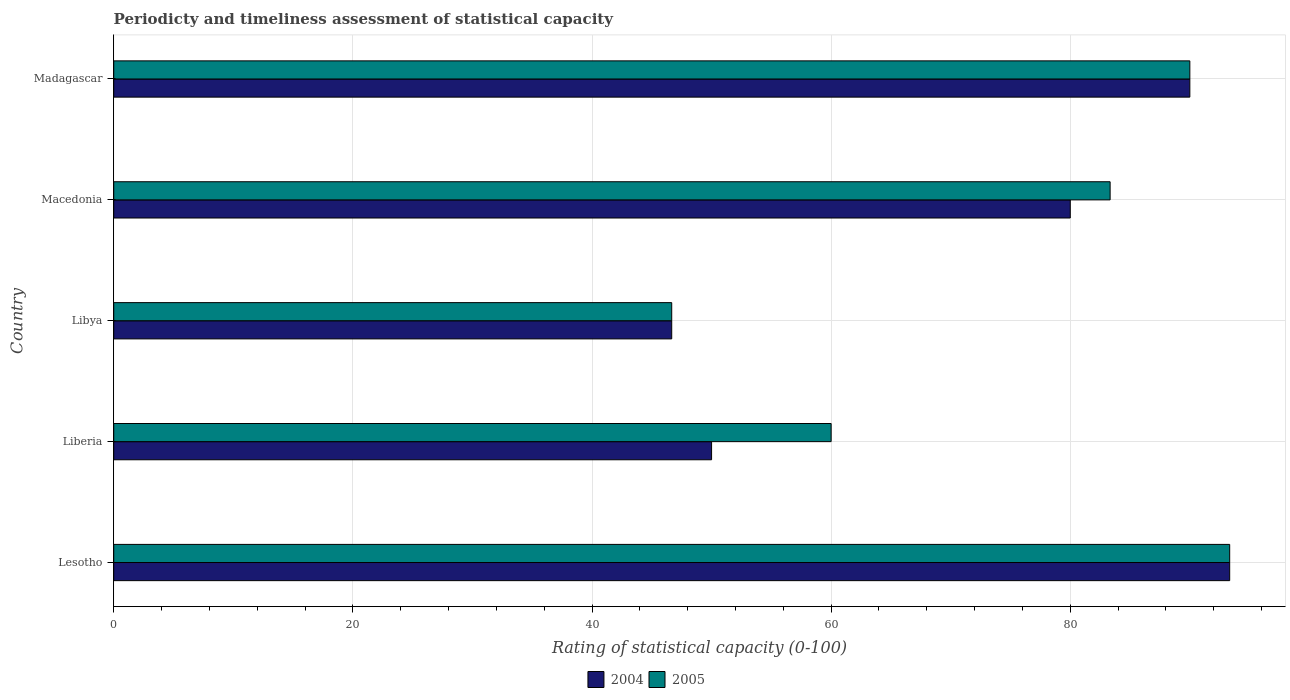Are the number of bars per tick equal to the number of legend labels?
Make the answer very short. Yes. How many bars are there on the 2nd tick from the top?
Give a very brief answer. 2. How many bars are there on the 1st tick from the bottom?
Your response must be concise. 2. What is the label of the 3rd group of bars from the top?
Give a very brief answer. Libya. In how many cases, is the number of bars for a given country not equal to the number of legend labels?
Your answer should be compact. 0. What is the rating of statistical capacity in 2005 in Libya?
Your response must be concise. 46.67. Across all countries, what is the maximum rating of statistical capacity in 2005?
Provide a short and direct response. 93.33. Across all countries, what is the minimum rating of statistical capacity in 2005?
Give a very brief answer. 46.67. In which country was the rating of statistical capacity in 2004 maximum?
Ensure brevity in your answer.  Lesotho. In which country was the rating of statistical capacity in 2005 minimum?
Provide a succinct answer. Libya. What is the total rating of statistical capacity in 2004 in the graph?
Keep it short and to the point. 360. What is the difference between the rating of statistical capacity in 2005 in Libya and the rating of statistical capacity in 2004 in Lesotho?
Give a very brief answer. -46.67. What is the average rating of statistical capacity in 2004 per country?
Keep it short and to the point. 72. What is the ratio of the rating of statistical capacity in 2005 in Liberia to that in Libya?
Provide a succinct answer. 1.29. Is the rating of statistical capacity in 2005 in Lesotho less than that in Libya?
Make the answer very short. No. What is the difference between the highest and the second highest rating of statistical capacity in 2004?
Your answer should be very brief. 3.33. What is the difference between the highest and the lowest rating of statistical capacity in 2004?
Your answer should be compact. 46.67. What does the 1st bar from the bottom in Libya represents?
Provide a short and direct response. 2004. How many bars are there?
Ensure brevity in your answer.  10. Does the graph contain any zero values?
Make the answer very short. No. How many legend labels are there?
Your answer should be very brief. 2. How are the legend labels stacked?
Ensure brevity in your answer.  Horizontal. What is the title of the graph?
Make the answer very short. Periodicty and timeliness assessment of statistical capacity. Does "1984" appear as one of the legend labels in the graph?
Offer a very short reply. No. What is the label or title of the X-axis?
Your answer should be compact. Rating of statistical capacity (0-100). What is the label or title of the Y-axis?
Your answer should be compact. Country. What is the Rating of statistical capacity (0-100) in 2004 in Lesotho?
Your answer should be very brief. 93.33. What is the Rating of statistical capacity (0-100) of 2005 in Lesotho?
Keep it short and to the point. 93.33. What is the Rating of statistical capacity (0-100) in 2004 in Liberia?
Offer a terse response. 50. What is the Rating of statistical capacity (0-100) in 2005 in Liberia?
Your answer should be very brief. 60. What is the Rating of statistical capacity (0-100) of 2004 in Libya?
Offer a very short reply. 46.67. What is the Rating of statistical capacity (0-100) in 2005 in Libya?
Your answer should be compact. 46.67. What is the Rating of statistical capacity (0-100) of 2004 in Macedonia?
Offer a very short reply. 80. What is the Rating of statistical capacity (0-100) of 2005 in Macedonia?
Offer a very short reply. 83.33. What is the Rating of statistical capacity (0-100) of 2004 in Madagascar?
Provide a succinct answer. 90. What is the Rating of statistical capacity (0-100) in 2005 in Madagascar?
Make the answer very short. 90. Across all countries, what is the maximum Rating of statistical capacity (0-100) of 2004?
Keep it short and to the point. 93.33. Across all countries, what is the maximum Rating of statistical capacity (0-100) in 2005?
Provide a short and direct response. 93.33. Across all countries, what is the minimum Rating of statistical capacity (0-100) in 2004?
Offer a terse response. 46.67. Across all countries, what is the minimum Rating of statistical capacity (0-100) in 2005?
Your response must be concise. 46.67. What is the total Rating of statistical capacity (0-100) in 2004 in the graph?
Offer a very short reply. 360. What is the total Rating of statistical capacity (0-100) of 2005 in the graph?
Your answer should be compact. 373.33. What is the difference between the Rating of statistical capacity (0-100) of 2004 in Lesotho and that in Liberia?
Provide a succinct answer. 43.33. What is the difference between the Rating of statistical capacity (0-100) of 2005 in Lesotho and that in Liberia?
Offer a very short reply. 33.33. What is the difference between the Rating of statistical capacity (0-100) in 2004 in Lesotho and that in Libya?
Provide a short and direct response. 46.67. What is the difference between the Rating of statistical capacity (0-100) of 2005 in Lesotho and that in Libya?
Keep it short and to the point. 46.67. What is the difference between the Rating of statistical capacity (0-100) of 2004 in Lesotho and that in Macedonia?
Give a very brief answer. 13.33. What is the difference between the Rating of statistical capacity (0-100) in 2005 in Lesotho and that in Macedonia?
Make the answer very short. 10. What is the difference between the Rating of statistical capacity (0-100) of 2005 in Lesotho and that in Madagascar?
Offer a terse response. 3.33. What is the difference between the Rating of statistical capacity (0-100) of 2005 in Liberia and that in Libya?
Keep it short and to the point. 13.33. What is the difference between the Rating of statistical capacity (0-100) of 2004 in Liberia and that in Macedonia?
Give a very brief answer. -30. What is the difference between the Rating of statistical capacity (0-100) of 2005 in Liberia and that in Macedonia?
Provide a succinct answer. -23.33. What is the difference between the Rating of statistical capacity (0-100) in 2004 in Libya and that in Macedonia?
Your response must be concise. -33.33. What is the difference between the Rating of statistical capacity (0-100) of 2005 in Libya and that in Macedonia?
Your answer should be very brief. -36.67. What is the difference between the Rating of statistical capacity (0-100) of 2004 in Libya and that in Madagascar?
Provide a short and direct response. -43.33. What is the difference between the Rating of statistical capacity (0-100) in 2005 in Libya and that in Madagascar?
Give a very brief answer. -43.33. What is the difference between the Rating of statistical capacity (0-100) in 2004 in Macedonia and that in Madagascar?
Your answer should be compact. -10. What is the difference between the Rating of statistical capacity (0-100) of 2005 in Macedonia and that in Madagascar?
Your response must be concise. -6.67. What is the difference between the Rating of statistical capacity (0-100) of 2004 in Lesotho and the Rating of statistical capacity (0-100) of 2005 in Liberia?
Offer a very short reply. 33.33. What is the difference between the Rating of statistical capacity (0-100) in 2004 in Lesotho and the Rating of statistical capacity (0-100) in 2005 in Libya?
Your answer should be compact. 46.67. What is the difference between the Rating of statistical capacity (0-100) of 2004 in Lesotho and the Rating of statistical capacity (0-100) of 2005 in Macedonia?
Your answer should be very brief. 10. What is the difference between the Rating of statistical capacity (0-100) of 2004 in Lesotho and the Rating of statistical capacity (0-100) of 2005 in Madagascar?
Make the answer very short. 3.33. What is the difference between the Rating of statistical capacity (0-100) of 2004 in Liberia and the Rating of statistical capacity (0-100) of 2005 in Libya?
Your answer should be very brief. 3.33. What is the difference between the Rating of statistical capacity (0-100) of 2004 in Liberia and the Rating of statistical capacity (0-100) of 2005 in Macedonia?
Make the answer very short. -33.33. What is the difference between the Rating of statistical capacity (0-100) of 2004 in Liberia and the Rating of statistical capacity (0-100) of 2005 in Madagascar?
Provide a succinct answer. -40. What is the difference between the Rating of statistical capacity (0-100) of 2004 in Libya and the Rating of statistical capacity (0-100) of 2005 in Macedonia?
Provide a succinct answer. -36.67. What is the difference between the Rating of statistical capacity (0-100) in 2004 in Libya and the Rating of statistical capacity (0-100) in 2005 in Madagascar?
Make the answer very short. -43.33. What is the difference between the Rating of statistical capacity (0-100) in 2004 in Macedonia and the Rating of statistical capacity (0-100) in 2005 in Madagascar?
Provide a succinct answer. -10. What is the average Rating of statistical capacity (0-100) of 2004 per country?
Keep it short and to the point. 72. What is the average Rating of statistical capacity (0-100) of 2005 per country?
Your response must be concise. 74.67. What is the difference between the Rating of statistical capacity (0-100) in 2004 and Rating of statistical capacity (0-100) in 2005 in Libya?
Your response must be concise. 0. What is the difference between the Rating of statistical capacity (0-100) in 2004 and Rating of statistical capacity (0-100) in 2005 in Macedonia?
Keep it short and to the point. -3.33. What is the difference between the Rating of statistical capacity (0-100) in 2004 and Rating of statistical capacity (0-100) in 2005 in Madagascar?
Your response must be concise. 0. What is the ratio of the Rating of statistical capacity (0-100) of 2004 in Lesotho to that in Liberia?
Keep it short and to the point. 1.87. What is the ratio of the Rating of statistical capacity (0-100) of 2005 in Lesotho to that in Liberia?
Give a very brief answer. 1.56. What is the ratio of the Rating of statistical capacity (0-100) of 2004 in Lesotho to that in Libya?
Your answer should be compact. 2. What is the ratio of the Rating of statistical capacity (0-100) of 2005 in Lesotho to that in Macedonia?
Ensure brevity in your answer.  1.12. What is the ratio of the Rating of statistical capacity (0-100) in 2004 in Lesotho to that in Madagascar?
Make the answer very short. 1.04. What is the ratio of the Rating of statistical capacity (0-100) in 2005 in Lesotho to that in Madagascar?
Make the answer very short. 1.04. What is the ratio of the Rating of statistical capacity (0-100) of 2004 in Liberia to that in Libya?
Offer a very short reply. 1.07. What is the ratio of the Rating of statistical capacity (0-100) of 2005 in Liberia to that in Macedonia?
Ensure brevity in your answer.  0.72. What is the ratio of the Rating of statistical capacity (0-100) in 2004 in Liberia to that in Madagascar?
Provide a succinct answer. 0.56. What is the ratio of the Rating of statistical capacity (0-100) in 2005 in Liberia to that in Madagascar?
Your answer should be very brief. 0.67. What is the ratio of the Rating of statistical capacity (0-100) in 2004 in Libya to that in Macedonia?
Give a very brief answer. 0.58. What is the ratio of the Rating of statistical capacity (0-100) in 2005 in Libya to that in Macedonia?
Offer a very short reply. 0.56. What is the ratio of the Rating of statistical capacity (0-100) of 2004 in Libya to that in Madagascar?
Provide a short and direct response. 0.52. What is the ratio of the Rating of statistical capacity (0-100) of 2005 in Libya to that in Madagascar?
Your answer should be very brief. 0.52. What is the ratio of the Rating of statistical capacity (0-100) of 2004 in Macedonia to that in Madagascar?
Your answer should be very brief. 0.89. What is the ratio of the Rating of statistical capacity (0-100) of 2005 in Macedonia to that in Madagascar?
Offer a very short reply. 0.93. What is the difference between the highest and the second highest Rating of statistical capacity (0-100) in 2004?
Offer a terse response. 3.33. What is the difference between the highest and the lowest Rating of statistical capacity (0-100) in 2004?
Provide a succinct answer. 46.67. What is the difference between the highest and the lowest Rating of statistical capacity (0-100) in 2005?
Offer a very short reply. 46.67. 